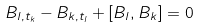Convert formula to latex. <formula><loc_0><loc_0><loc_500><loc_500>B _ { l , t _ { k } } - B _ { k , t _ { l } } + [ B _ { l } , B _ { k } ] = 0</formula> 